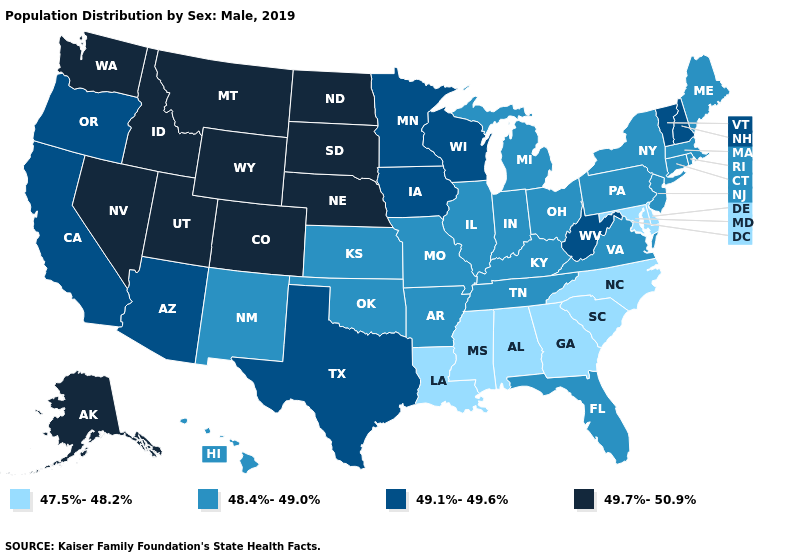What is the value of New York?
Quick response, please. 48.4%-49.0%. What is the value of Kentucky?
Write a very short answer. 48.4%-49.0%. What is the value of Minnesota?
Write a very short answer. 49.1%-49.6%. Which states have the lowest value in the USA?
Answer briefly. Alabama, Delaware, Georgia, Louisiana, Maryland, Mississippi, North Carolina, South Carolina. What is the value of Tennessee?
Keep it brief. 48.4%-49.0%. What is the lowest value in the South?
Be succinct. 47.5%-48.2%. Name the states that have a value in the range 49.7%-50.9%?
Keep it brief. Alaska, Colorado, Idaho, Montana, Nebraska, Nevada, North Dakota, South Dakota, Utah, Washington, Wyoming. What is the lowest value in states that border Minnesota?
Give a very brief answer. 49.1%-49.6%. What is the highest value in the USA?
Be succinct. 49.7%-50.9%. Which states hav the highest value in the Northeast?
Short answer required. New Hampshire, Vermont. Does Maryland have the lowest value in the USA?
Write a very short answer. Yes. What is the value of Illinois?
Be succinct. 48.4%-49.0%. Does the map have missing data?
Quick response, please. No. Does Montana have the same value as Nebraska?
Concise answer only. Yes. Among the states that border Arkansas , which have the lowest value?
Quick response, please. Louisiana, Mississippi. 